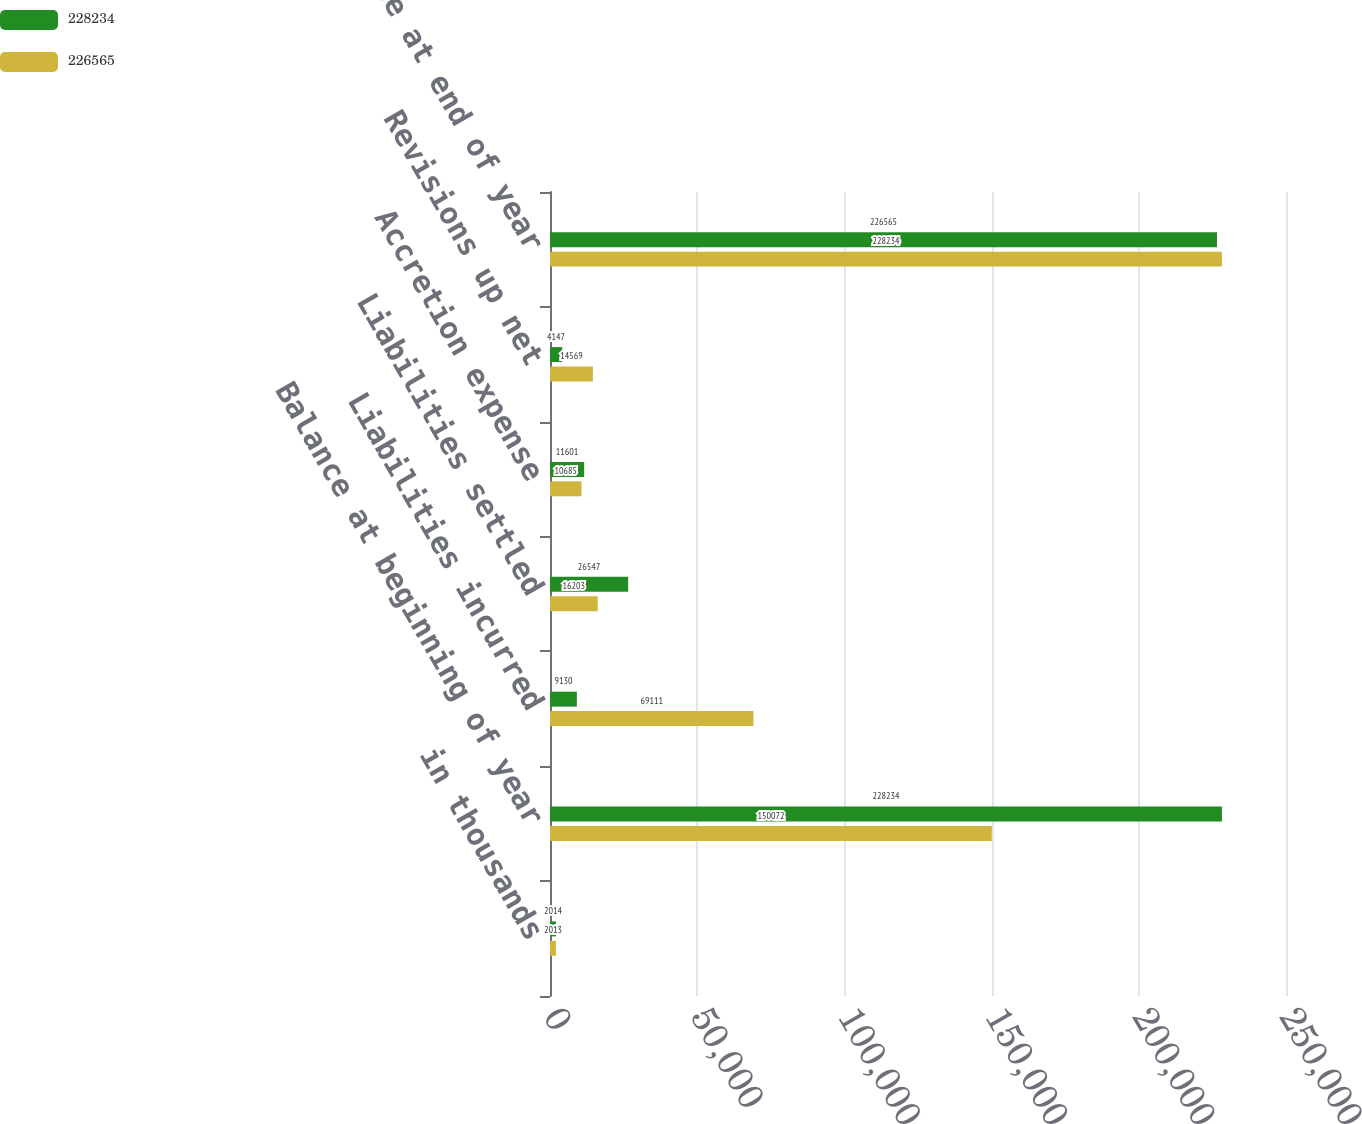Convert chart. <chart><loc_0><loc_0><loc_500><loc_500><stacked_bar_chart><ecel><fcel>in thousands<fcel>Balance at beginning of year<fcel>Liabilities incurred<fcel>Liabilities settled<fcel>Accretion expense<fcel>Revisions up net<fcel>Balance at end of year<nl><fcel>228234<fcel>2014<fcel>228234<fcel>9130<fcel>26547<fcel>11601<fcel>4147<fcel>226565<nl><fcel>226565<fcel>2013<fcel>150072<fcel>69111<fcel>16203<fcel>10685<fcel>14569<fcel>228234<nl></chart> 